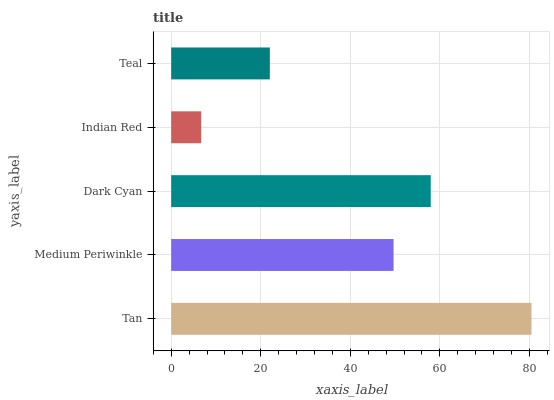Is Indian Red the minimum?
Answer yes or no. Yes. Is Tan the maximum?
Answer yes or no. Yes. Is Medium Periwinkle the minimum?
Answer yes or no. No. Is Medium Periwinkle the maximum?
Answer yes or no. No. Is Tan greater than Medium Periwinkle?
Answer yes or no. Yes. Is Medium Periwinkle less than Tan?
Answer yes or no. Yes. Is Medium Periwinkle greater than Tan?
Answer yes or no. No. Is Tan less than Medium Periwinkle?
Answer yes or no. No. Is Medium Periwinkle the high median?
Answer yes or no. Yes. Is Medium Periwinkle the low median?
Answer yes or no. Yes. Is Dark Cyan the high median?
Answer yes or no. No. Is Dark Cyan the low median?
Answer yes or no. No. 